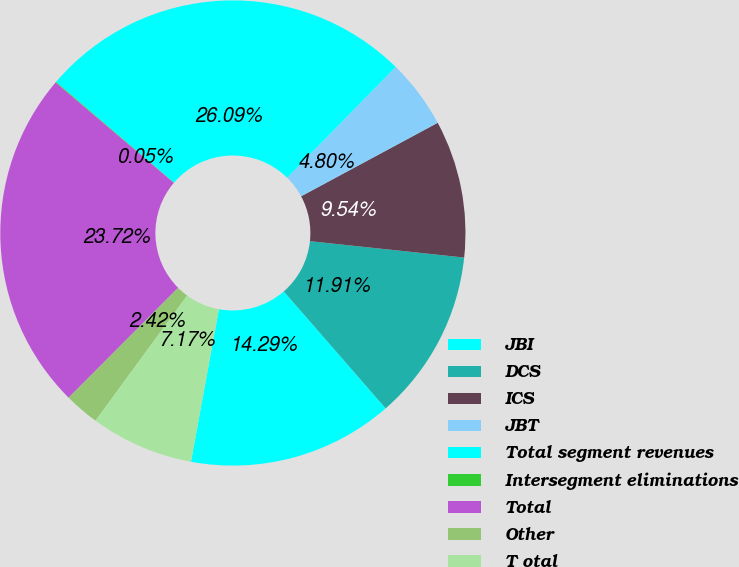Convert chart to OTSL. <chart><loc_0><loc_0><loc_500><loc_500><pie_chart><fcel>JBI<fcel>DCS<fcel>ICS<fcel>JBT<fcel>Total segment revenues<fcel>Intersegment eliminations<fcel>Total<fcel>Other<fcel>T otal<nl><fcel>14.29%<fcel>11.91%<fcel>9.54%<fcel>4.8%<fcel>26.09%<fcel>0.05%<fcel>23.72%<fcel>2.42%<fcel>7.17%<nl></chart> 